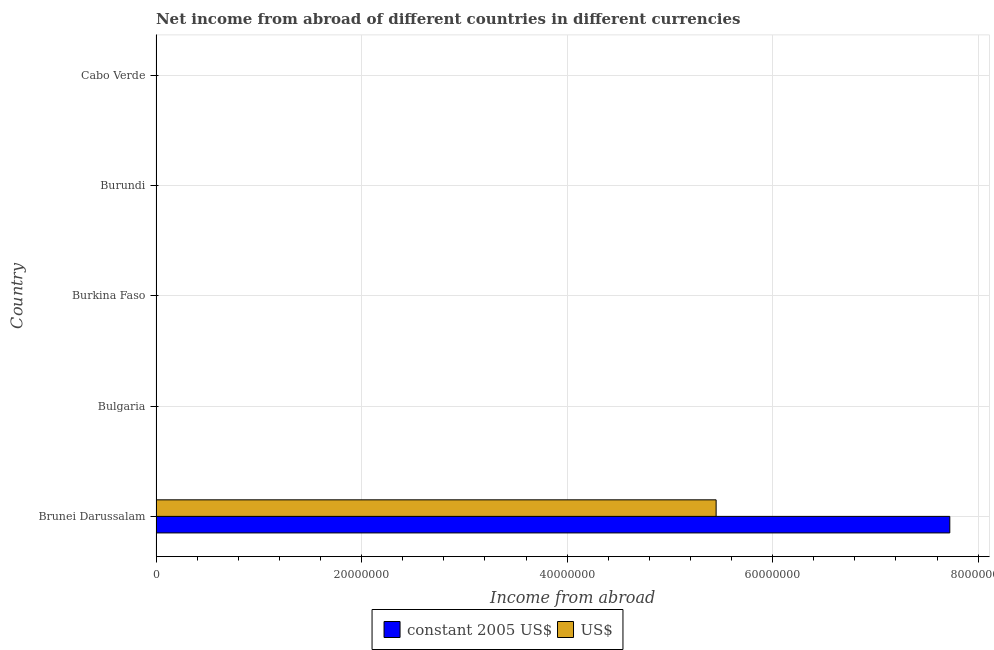Are the number of bars per tick equal to the number of legend labels?
Your response must be concise. No. Are the number of bars on each tick of the Y-axis equal?
Offer a very short reply. No. How many bars are there on the 5th tick from the bottom?
Make the answer very short. 0. What is the income from abroad in us$ in Burkina Faso?
Keep it short and to the point. 0. Across all countries, what is the maximum income from abroad in constant 2005 us$?
Make the answer very short. 7.72e+07. Across all countries, what is the minimum income from abroad in constant 2005 us$?
Your response must be concise. 0. In which country was the income from abroad in us$ maximum?
Offer a terse response. Brunei Darussalam. What is the total income from abroad in constant 2005 us$ in the graph?
Your answer should be very brief. 7.72e+07. What is the average income from abroad in constant 2005 us$ per country?
Your answer should be compact. 1.54e+07. What is the difference between the income from abroad in us$ and income from abroad in constant 2005 us$ in Brunei Darussalam?
Ensure brevity in your answer.  -2.27e+07. In how many countries, is the income from abroad in us$ greater than 44000000 units?
Make the answer very short. 1. What is the difference between the highest and the lowest income from abroad in constant 2005 us$?
Your response must be concise. 7.72e+07. In how many countries, is the income from abroad in us$ greater than the average income from abroad in us$ taken over all countries?
Provide a succinct answer. 1. How many countries are there in the graph?
Provide a succinct answer. 5. Does the graph contain grids?
Give a very brief answer. Yes. Where does the legend appear in the graph?
Make the answer very short. Bottom center. What is the title of the graph?
Your answer should be very brief. Net income from abroad of different countries in different currencies. What is the label or title of the X-axis?
Provide a short and direct response. Income from abroad. What is the label or title of the Y-axis?
Keep it short and to the point. Country. What is the Income from abroad of constant 2005 US$ in Brunei Darussalam?
Ensure brevity in your answer.  7.72e+07. What is the Income from abroad in US$ in Brunei Darussalam?
Provide a succinct answer. 5.45e+07. What is the Income from abroad in constant 2005 US$ in Bulgaria?
Offer a very short reply. 0. What is the Income from abroad of US$ in Bulgaria?
Make the answer very short. 0. What is the Income from abroad in constant 2005 US$ in Burkina Faso?
Your answer should be compact. 0. What is the Income from abroad in constant 2005 US$ in Burundi?
Your answer should be compact. 0. What is the Income from abroad of constant 2005 US$ in Cabo Verde?
Give a very brief answer. 0. Across all countries, what is the maximum Income from abroad of constant 2005 US$?
Give a very brief answer. 7.72e+07. Across all countries, what is the maximum Income from abroad of US$?
Provide a short and direct response. 5.45e+07. Across all countries, what is the minimum Income from abroad in constant 2005 US$?
Offer a terse response. 0. What is the total Income from abroad in constant 2005 US$ in the graph?
Give a very brief answer. 7.72e+07. What is the total Income from abroad in US$ in the graph?
Offer a terse response. 5.45e+07. What is the average Income from abroad in constant 2005 US$ per country?
Your answer should be very brief. 1.54e+07. What is the average Income from abroad of US$ per country?
Provide a short and direct response. 1.09e+07. What is the difference between the Income from abroad of constant 2005 US$ and Income from abroad of US$ in Brunei Darussalam?
Make the answer very short. 2.27e+07. What is the difference between the highest and the lowest Income from abroad of constant 2005 US$?
Ensure brevity in your answer.  7.72e+07. What is the difference between the highest and the lowest Income from abroad in US$?
Offer a terse response. 5.45e+07. 